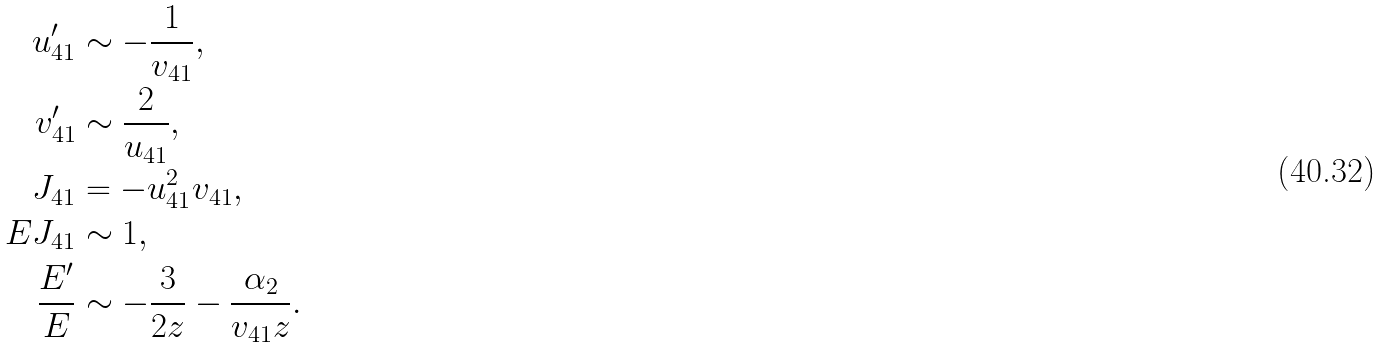Convert formula to latex. <formula><loc_0><loc_0><loc_500><loc_500>u _ { 4 1 } ^ { \prime } & \sim - \frac { 1 } { v _ { 4 1 } } , \\ v _ { 4 1 } ^ { \prime } & \sim \frac { 2 } { u _ { 4 1 } } , \\ J _ { 4 1 } & = - u _ { 4 1 } ^ { 2 } v _ { 4 1 } , \\ E J _ { 4 1 } & \sim 1 , \\ \frac { E ^ { \prime } } { E } & \sim - \frac { 3 } { 2 z } - \frac { \alpha _ { 2 } } { v _ { 4 1 } z } .</formula> 